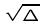<formula> <loc_0><loc_0><loc_500><loc_500>\sqrt { \Delta }</formula> 